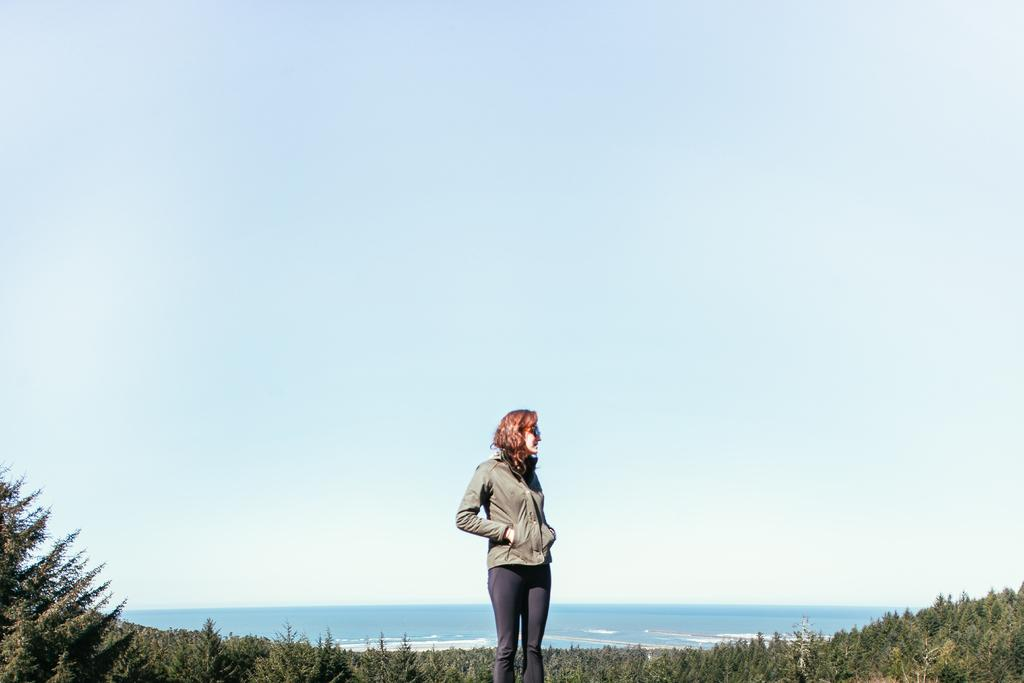Who is present in the image? There is a woman in the image. What type of clothing is the woman wearing? The woman is wearing a jacket, goggles, and trousers. What can be seen in the background of the image? There are many trees and the ocean in the background of the image. What is visible at the top of the image? The sky is visible at the top of the image. What type of poison is the woman holding in the image? There is no poison present in the image; the woman is wearing goggles and trousers. Can you see a donkey in the image? No, there is no donkey present in the image. 